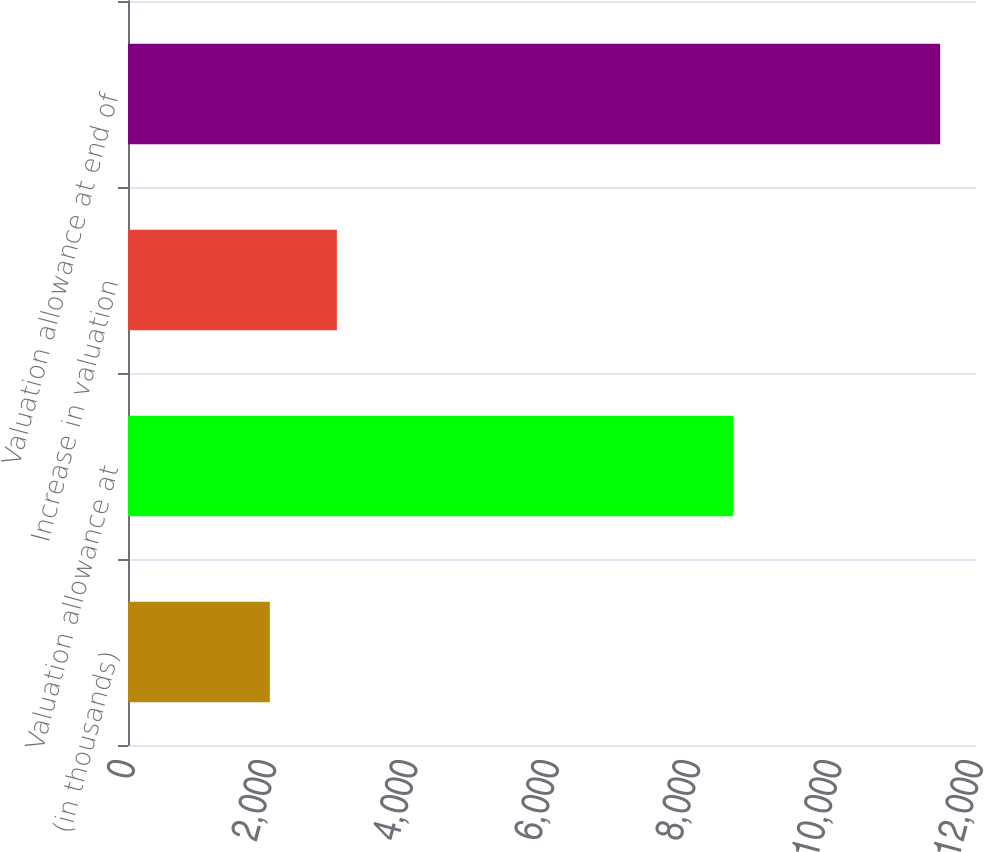Convert chart to OTSL. <chart><loc_0><loc_0><loc_500><loc_500><bar_chart><fcel>(in thousands)<fcel>Valuation allowance at<fcel>Increase in valuation<fcel>Valuation allowance at end of<nl><fcel>2007<fcel>8563<fcel>2955.6<fcel>11493<nl></chart> 